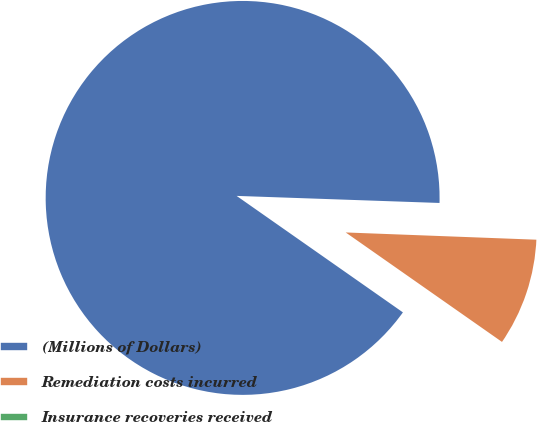<chart> <loc_0><loc_0><loc_500><loc_500><pie_chart><fcel>(Millions of Dollars)<fcel>Remediation costs incurred<fcel>Insurance recoveries received<nl><fcel>90.83%<fcel>9.12%<fcel>0.05%<nl></chart> 